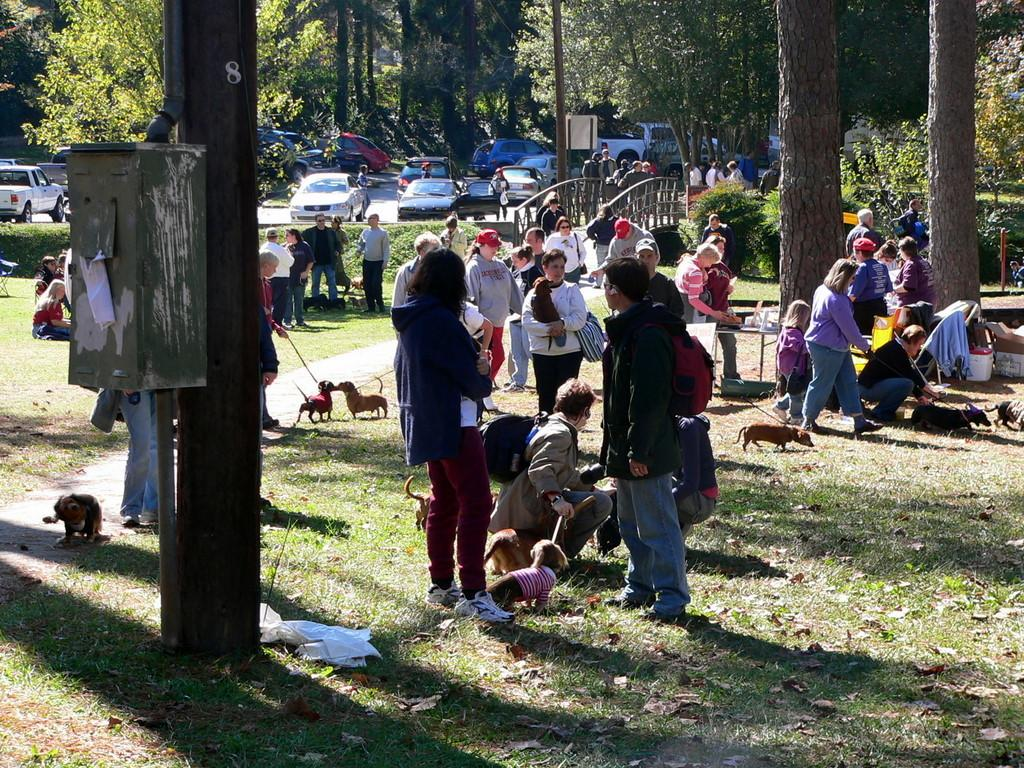What can be seen in the image involving multiple individuals? There is a group of people in the image. What else is present on the ground in the image? There are vehicles on the ground in the image. What type of natural scenery is visible in the background of the image? There are trees visible in the background of the image. Where is the throne located in the image? There is no throne present in the image. What type of pets can be seen interacting with the people in the image? There are no pets visible in the image. 